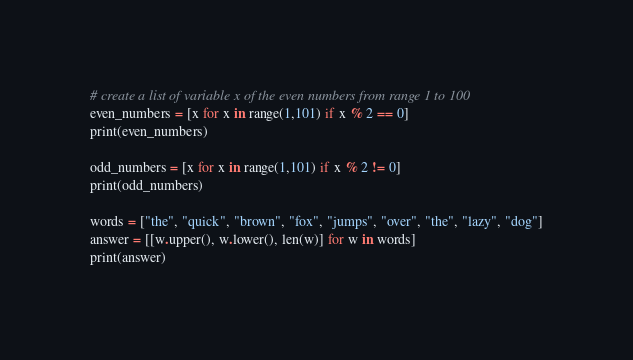<code> <loc_0><loc_0><loc_500><loc_500><_Python_>
# create a list of variable x of the even numbers from range 1 to 100
even_numbers = [x for x in range(1,101) if x % 2 == 0]
print(even_numbers)

odd_numbers = [x for x in range(1,101) if x % 2 != 0]
print(odd_numbers)

words = ["the", "quick", "brown", "fox", "jumps", "over", "the", "lazy", "dog"]
answer = [[w.upper(), w.lower(), len(w)] for w in words]
print(answer)
</code> 